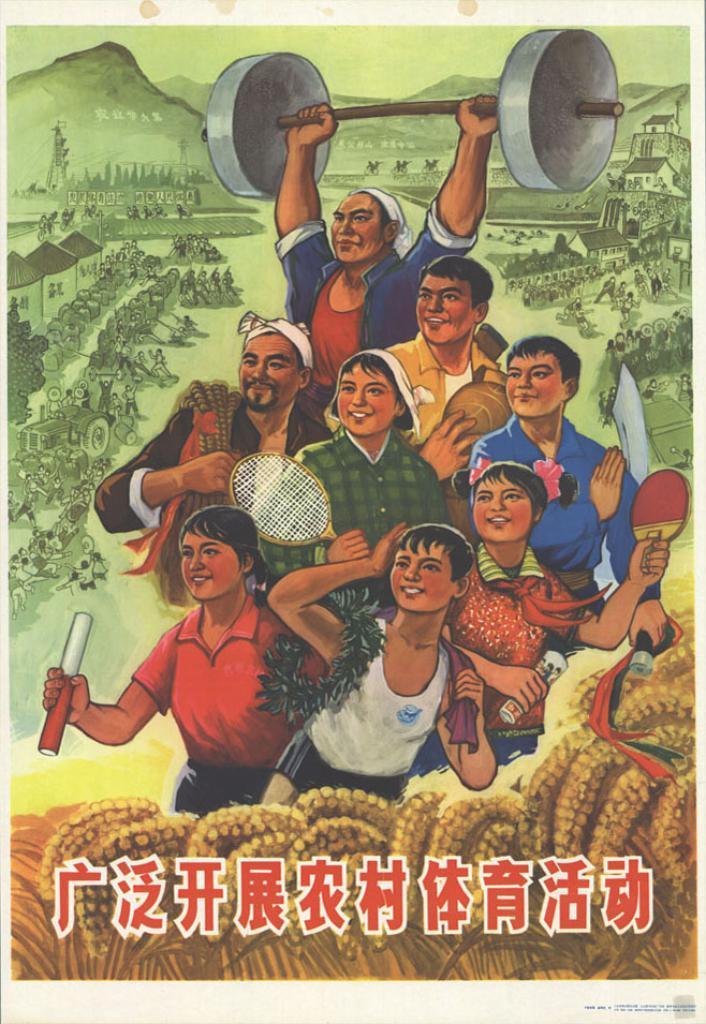In one or two sentences, can you explain what this image depicts? This picture contains a poster. In this picture, we see people are standing. Some of them are holding the rackets in their hands. At the bottom, we see some text written in some other language. In the background, we see buildings and people are standing. There are hills in the background. 